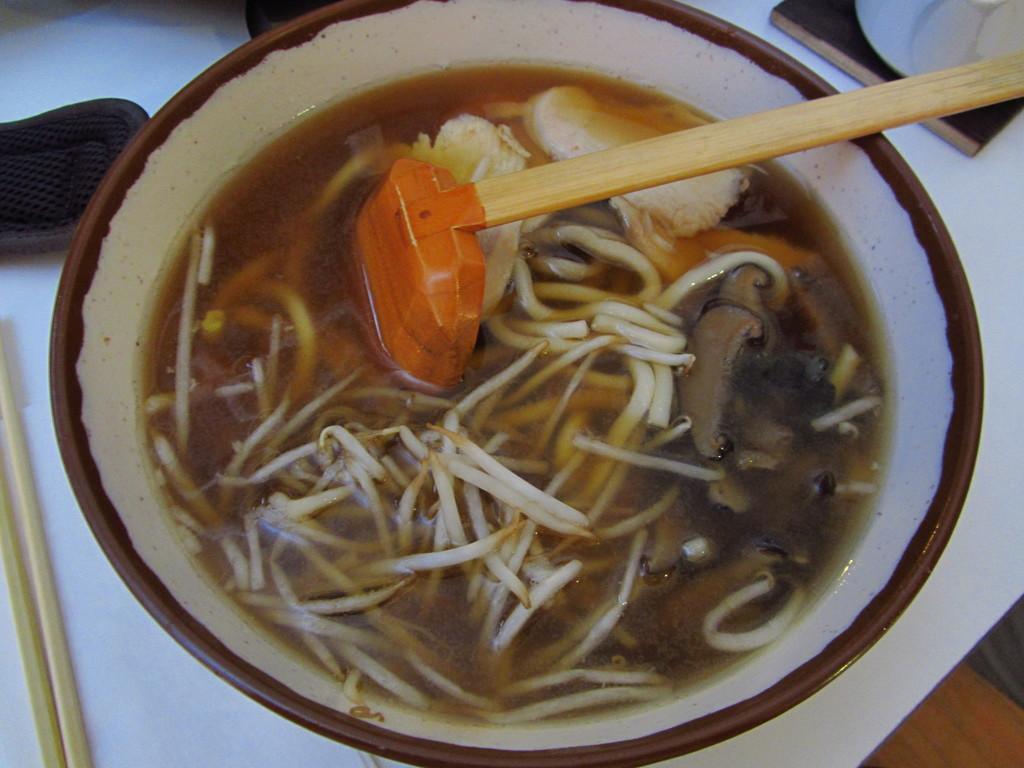In one or two sentences, can you explain what this image depicts? This image consists of a bowl and spoon in it. There are some eatables in the bowl. On the left side there are chopsticks. 